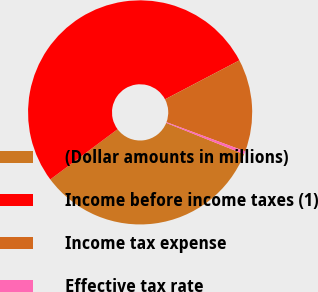Convert chart to OTSL. <chart><loc_0><loc_0><loc_500><loc_500><pie_chart><fcel>(Dollar amounts in millions)<fcel>Income before income taxes (1)<fcel>Income tax expense<fcel>Effective tax rate<nl><fcel>33.71%<fcel>52.52%<fcel>13.34%<fcel>0.43%<nl></chart> 